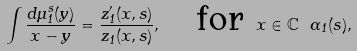<formula> <loc_0><loc_0><loc_500><loc_500>\int \frac { d \mu ^ { s } _ { 1 } ( y ) } { x - y } = \frac { z ^ { \prime } _ { 1 } ( x , s ) } { z _ { 1 } ( x , s ) } , \quad \text {for } x \in \mathbb { C } \ \Gamma _ { 1 } ( s ) ,</formula> 